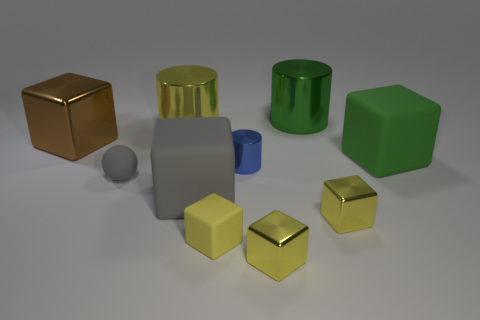Subtract all purple spheres. How many yellow blocks are left? 3 Subtract 2 blocks. How many blocks are left? 4 Subtract all gray blocks. How many blocks are left? 5 Subtract all tiny rubber cubes. How many cubes are left? 5 Subtract all red blocks. Subtract all red cylinders. How many blocks are left? 6 Subtract all balls. How many objects are left? 9 Add 7 green metallic things. How many green metallic things are left? 8 Add 7 green shiny balls. How many green shiny balls exist? 7 Subtract 0 blue balls. How many objects are left? 10 Subtract all purple cubes. Subtract all green matte blocks. How many objects are left? 9 